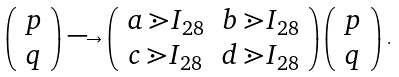<formula> <loc_0><loc_0><loc_500><loc_500>\left ( \begin{array} { c } p \\ q \\ \end{array} \right ) \longrightarrow \left ( \begin{array} { c c } a \, \mathbb { m } { I } _ { 2 8 } & b \, \mathbb { m } { I } _ { 2 8 } \\ c \, \mathbb { m } { I } _ { 2 8 } & d \, \mathbb { m } { I } _ { 2 8 } \\ \end{array} \right ) \left ( \begin{array} { c } p \\ q \\ \end{array} \right ) \, .</formula> 